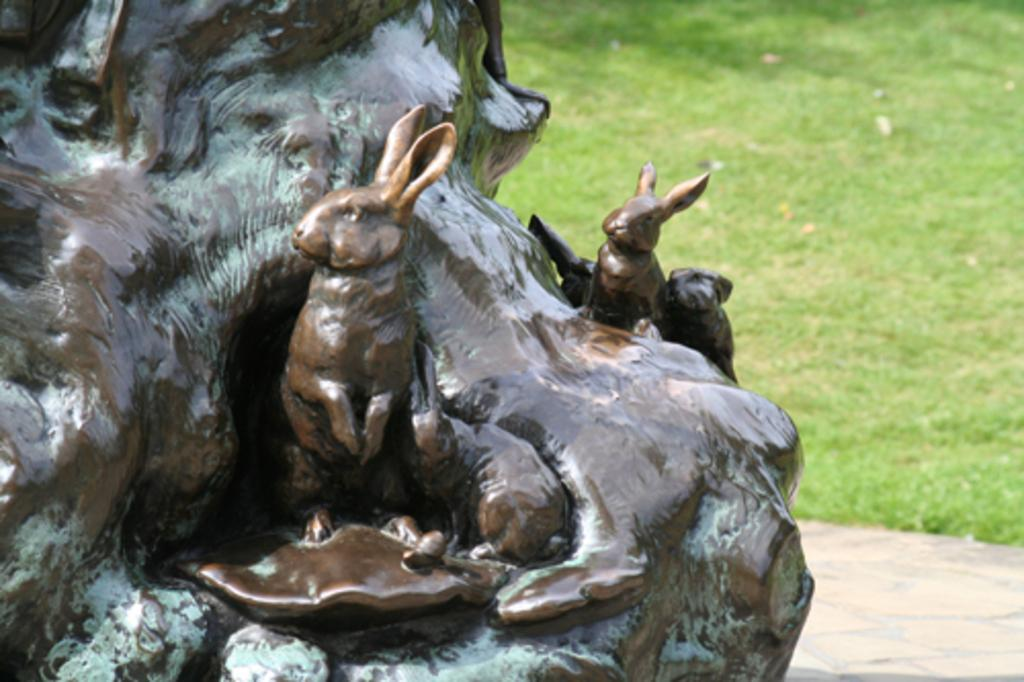What is the main subject of the image? There is a sculpture in the image. What can be seen in the background of the image? There is grassland in the background of the image. What type of question is being asked in the image? There is no question present in the image; it features a sculpture and grassland. Can you see a scarf or window in the image? No, there is no scarf or window present in the image. 